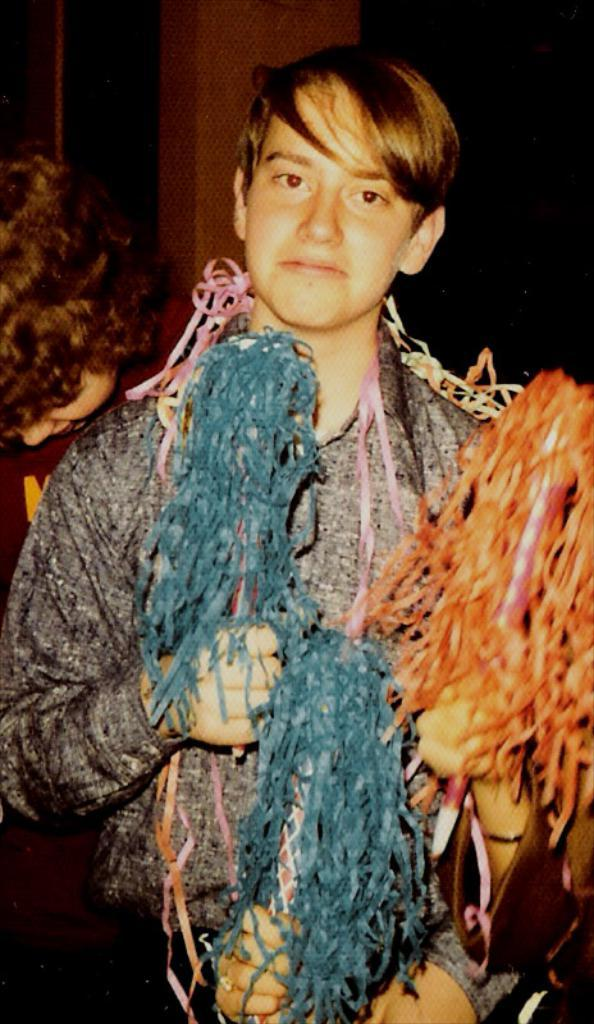Who is the main subject in the image? There is a boy in the image. What is the boy holding in his hand? The boy is holding crafted items in his hand. Can you describe the person behind the boy? There is another person behind the boy, and they are holding an item. Are there any other children in the image? Yes, there is another boy behind the other person. What type of income does the boy earn from his crafted items in the image? There is no information about the boy's income in the image, as it only shows him holding crafted items. Can you see any fairies in the image? No, there are no fairies present in the image. 